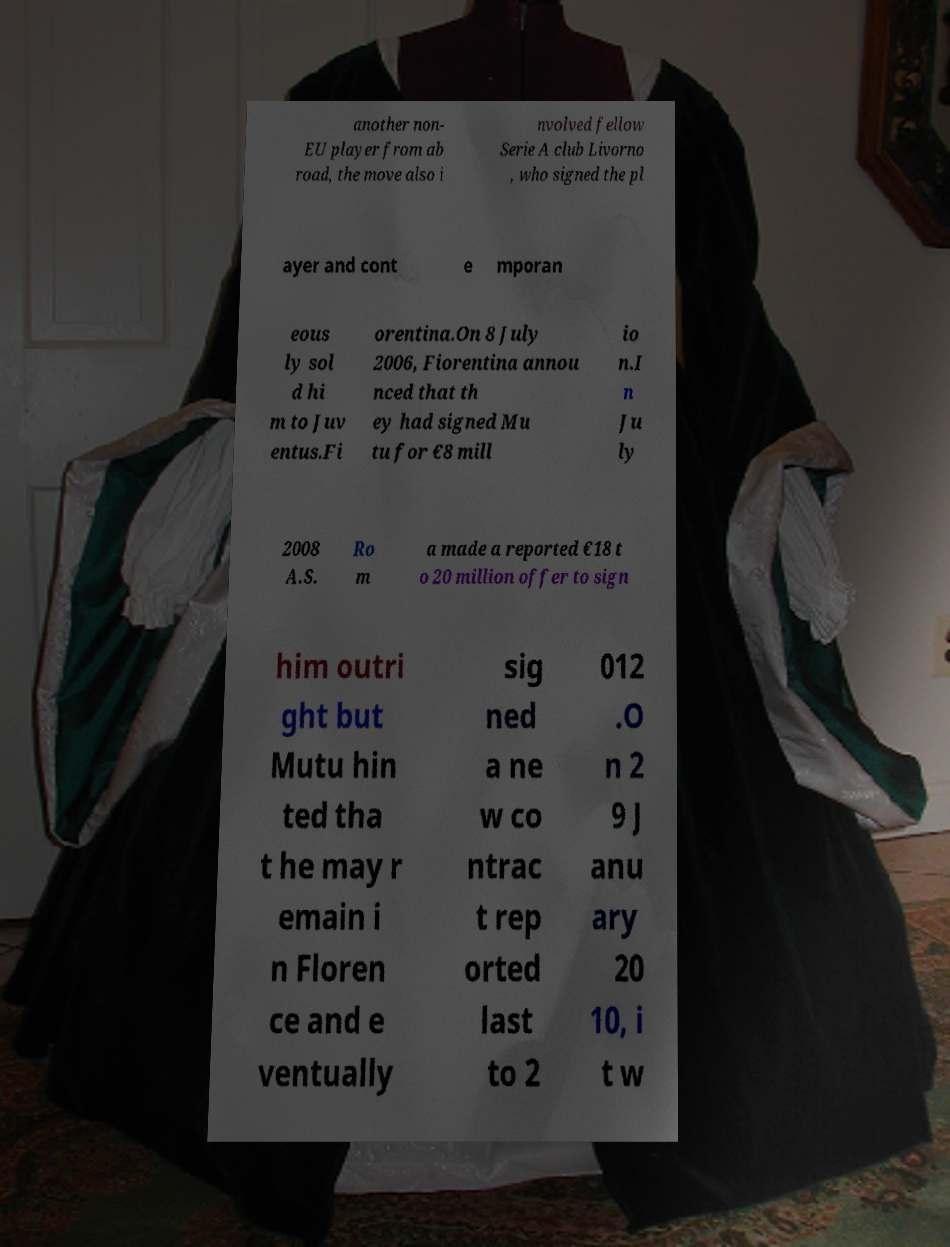Could you extract and type out the text from this image? another non- EU player from ab road, the move also i nvolved fellow Serie A club Livorno , who signed the pl ayer and cont e mporan eous ly sol d hi m to Juv entus.Fi orentina.On 8 July 2006, Fiorentina annou nced that th ey had signed Mu tu for €8 mill io n.I n Ju ly 2008 A.S. Ro m a made a reported €18 t o 20 million offer to sign him outri ght but Mutu hin ted tha t he may r emain i n Floren ce and e ventually sig ned a ne w co ntrac t rep orted last to 2 012 .O n 2 9 J anu ary 20 10, i t w 